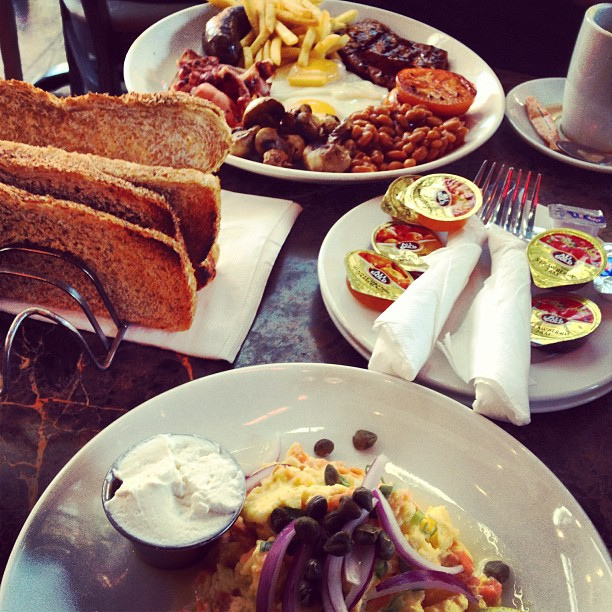In a realistic scenario, what could be the ingredients in the scrambled eggs? The scrambled eggs likely contain ingredients such as fresh eggs, diced onions, green peppers, a sprinkle of salt and pepper, and possibly some milk or cream to give them a fluffier texture. They may also have some garnishes like capers and purple onions for added flavor and presentation. 